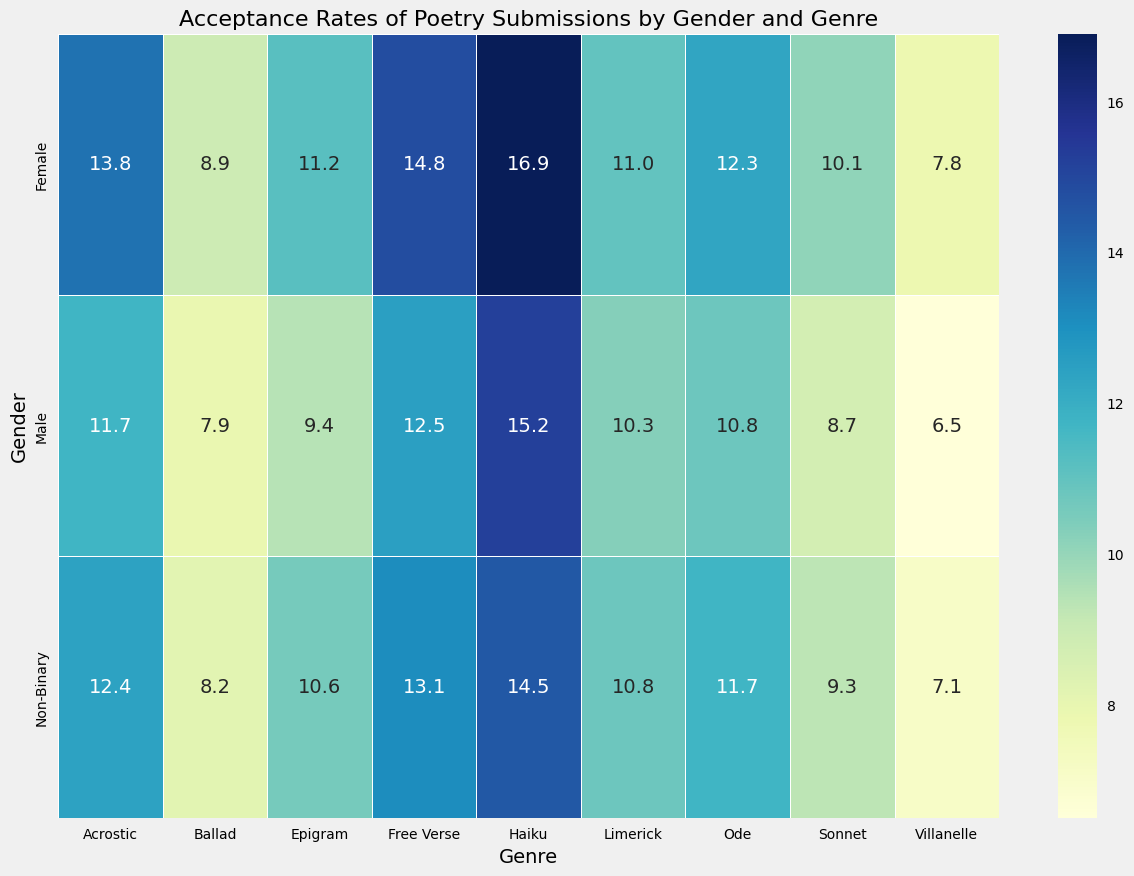How does the acceptance rate for Free Verse compare among Male, Female, and Non-Binary genders? First, locate the acceptance rate for Free Verse for all three genders. Male has 12.5%, Female has 14.8%, and Non-Binary has 13.1%. Compare these values. Female has the highest acceptance rate for Free Verse, followed by Non-Binary and then Male.
Answer: Female: 14.8%, Non-Binary: 13.1%, Male: 12.5% Which genre has the highest variance in acceptance rates among the three genders? Identify the acceptance rates for each genre across all three genders and calculate the variance or notice the spread visually. For Haiku, the rates are Male (15.2%), Female (16.9%), and Non-Binary (14.5%). This shows the largest spread.
Answer: Haiku Is the acceptance rate for Females consistently higher than Males across all genres? Go through each genre, comparing the acceptance rates of Females with Males. For most genres, Female acceptance rates are higher. However, for Ballad, Female (8.9%) is only slightly higher than Male (7.9%).
Answer: Yes, generally What is the average acceptance rate for Non-Binary authors across all genres? Sum the acceptance rates for Non-Binary across all genres: (13.1 + 14.5 + 9.3 + 7.1 + 10.8 + 12.4 + 10.6 + 11.7 + 8.2) = 97.7. Divide by the number of genres (9). The average acceptance rate is 97.7/9.
Answer: 10.9% Which genre has the lowest acceptance rate overall, and for which gender? Locate the lowest acceptance rates in the heatmap for each genre, regardless of gender. The lowest rate is Villanelle for Male (6.5%).
Answer: Villanelle, Male Does the acceptance rate for Acrostic differ more between Male and Female or between Female and Non-Binary? Calculate the difference between Male and Female (13.8% - 11.7% = 2.1%), then between Female and Non-Binary (13.8% - 12.4% = 1.4%). The difference is higher between Male and Female.
Answer: Male vs Female: 2.1%, Female vs Non-Binary: 1.4% Which gender-genre combination has the second-highest acceptance rate? Identify all the acceptance rates and sort them. The highest is Female Haiku (16.9%), and the second-highest is Male Haiku (15.2%).
Answer: Male Haiku For which genres is the acceptance rate for Female authors higher than 12%? Check each genre for Female and see which has an acceptance rate above 12%. Free Verse (14.8%), Haiku (16.9%), Acrostic (13.8%), and Ode (12.3%) are above 12%.
Answer: Free Verse, Haiku, Acrostic, Ode 